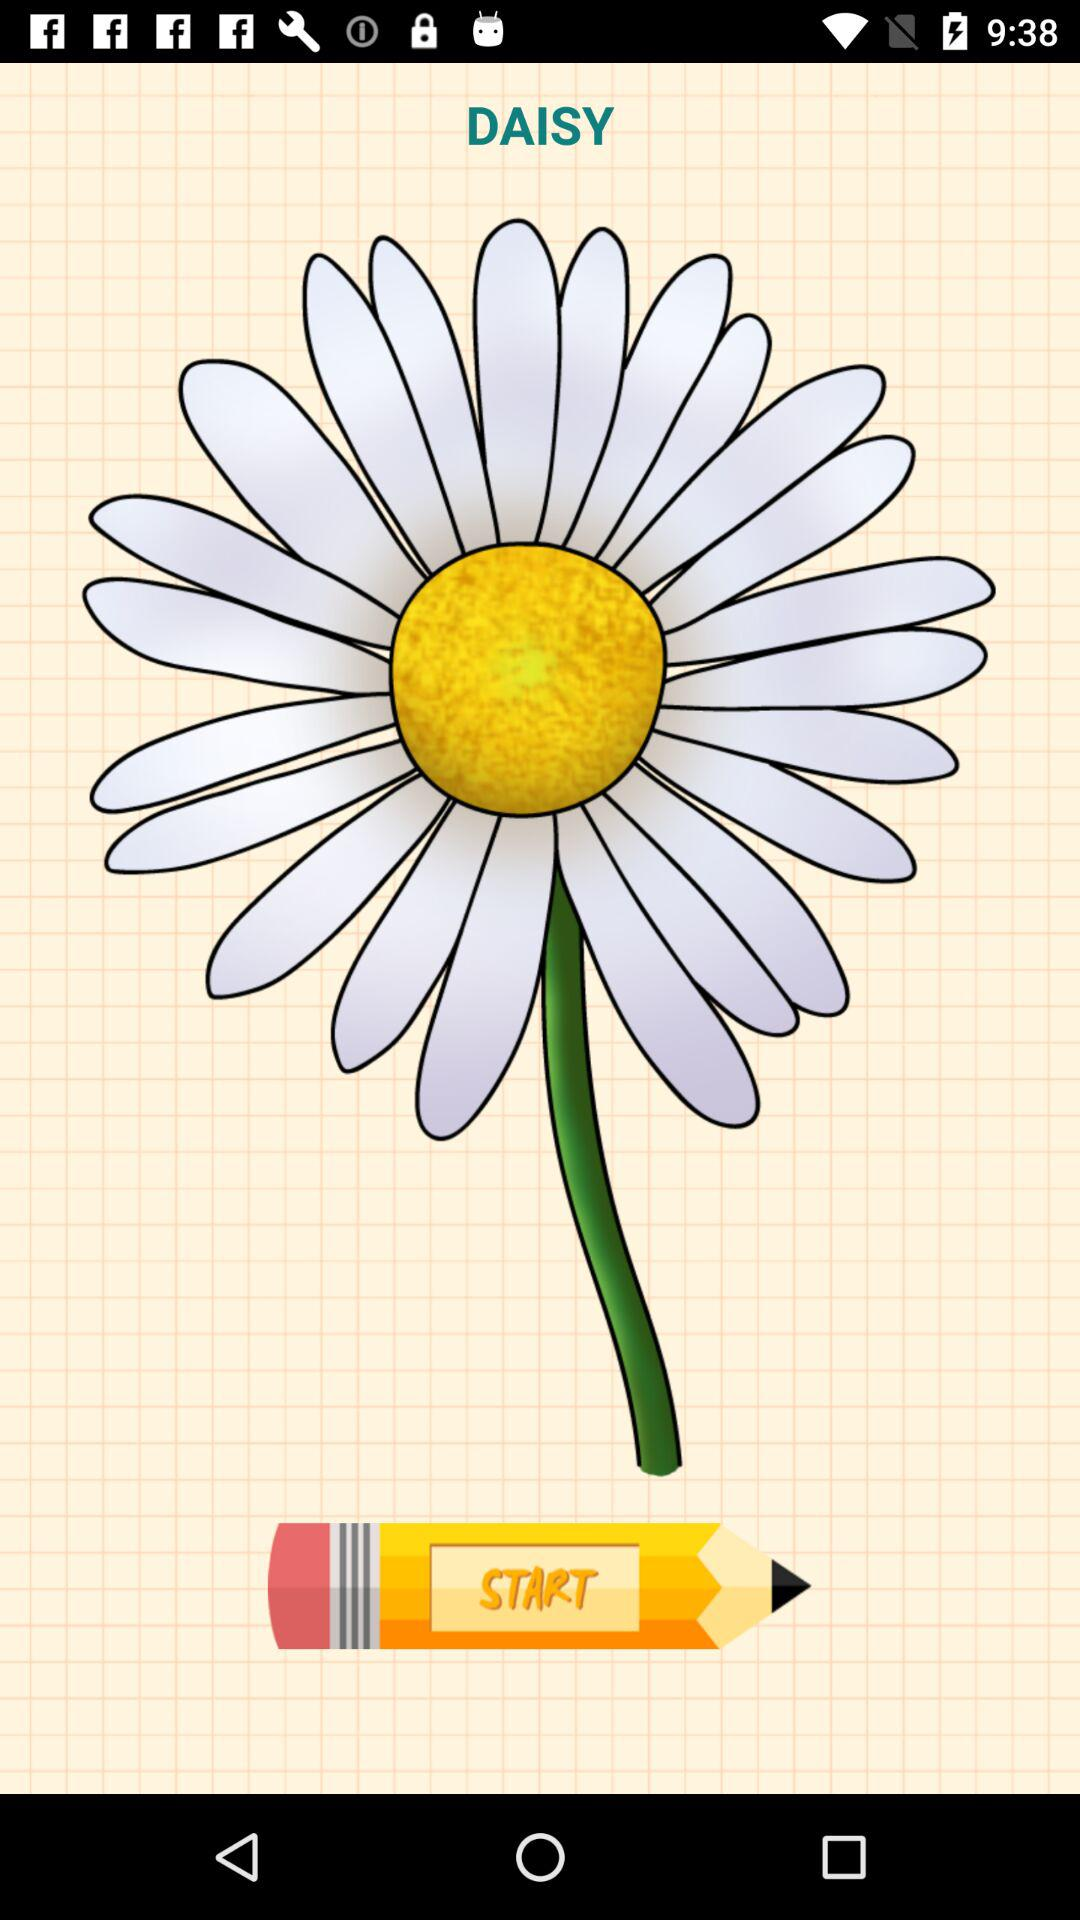What is the name of the flower shown on the screen? The name of the flower is Daisy. 